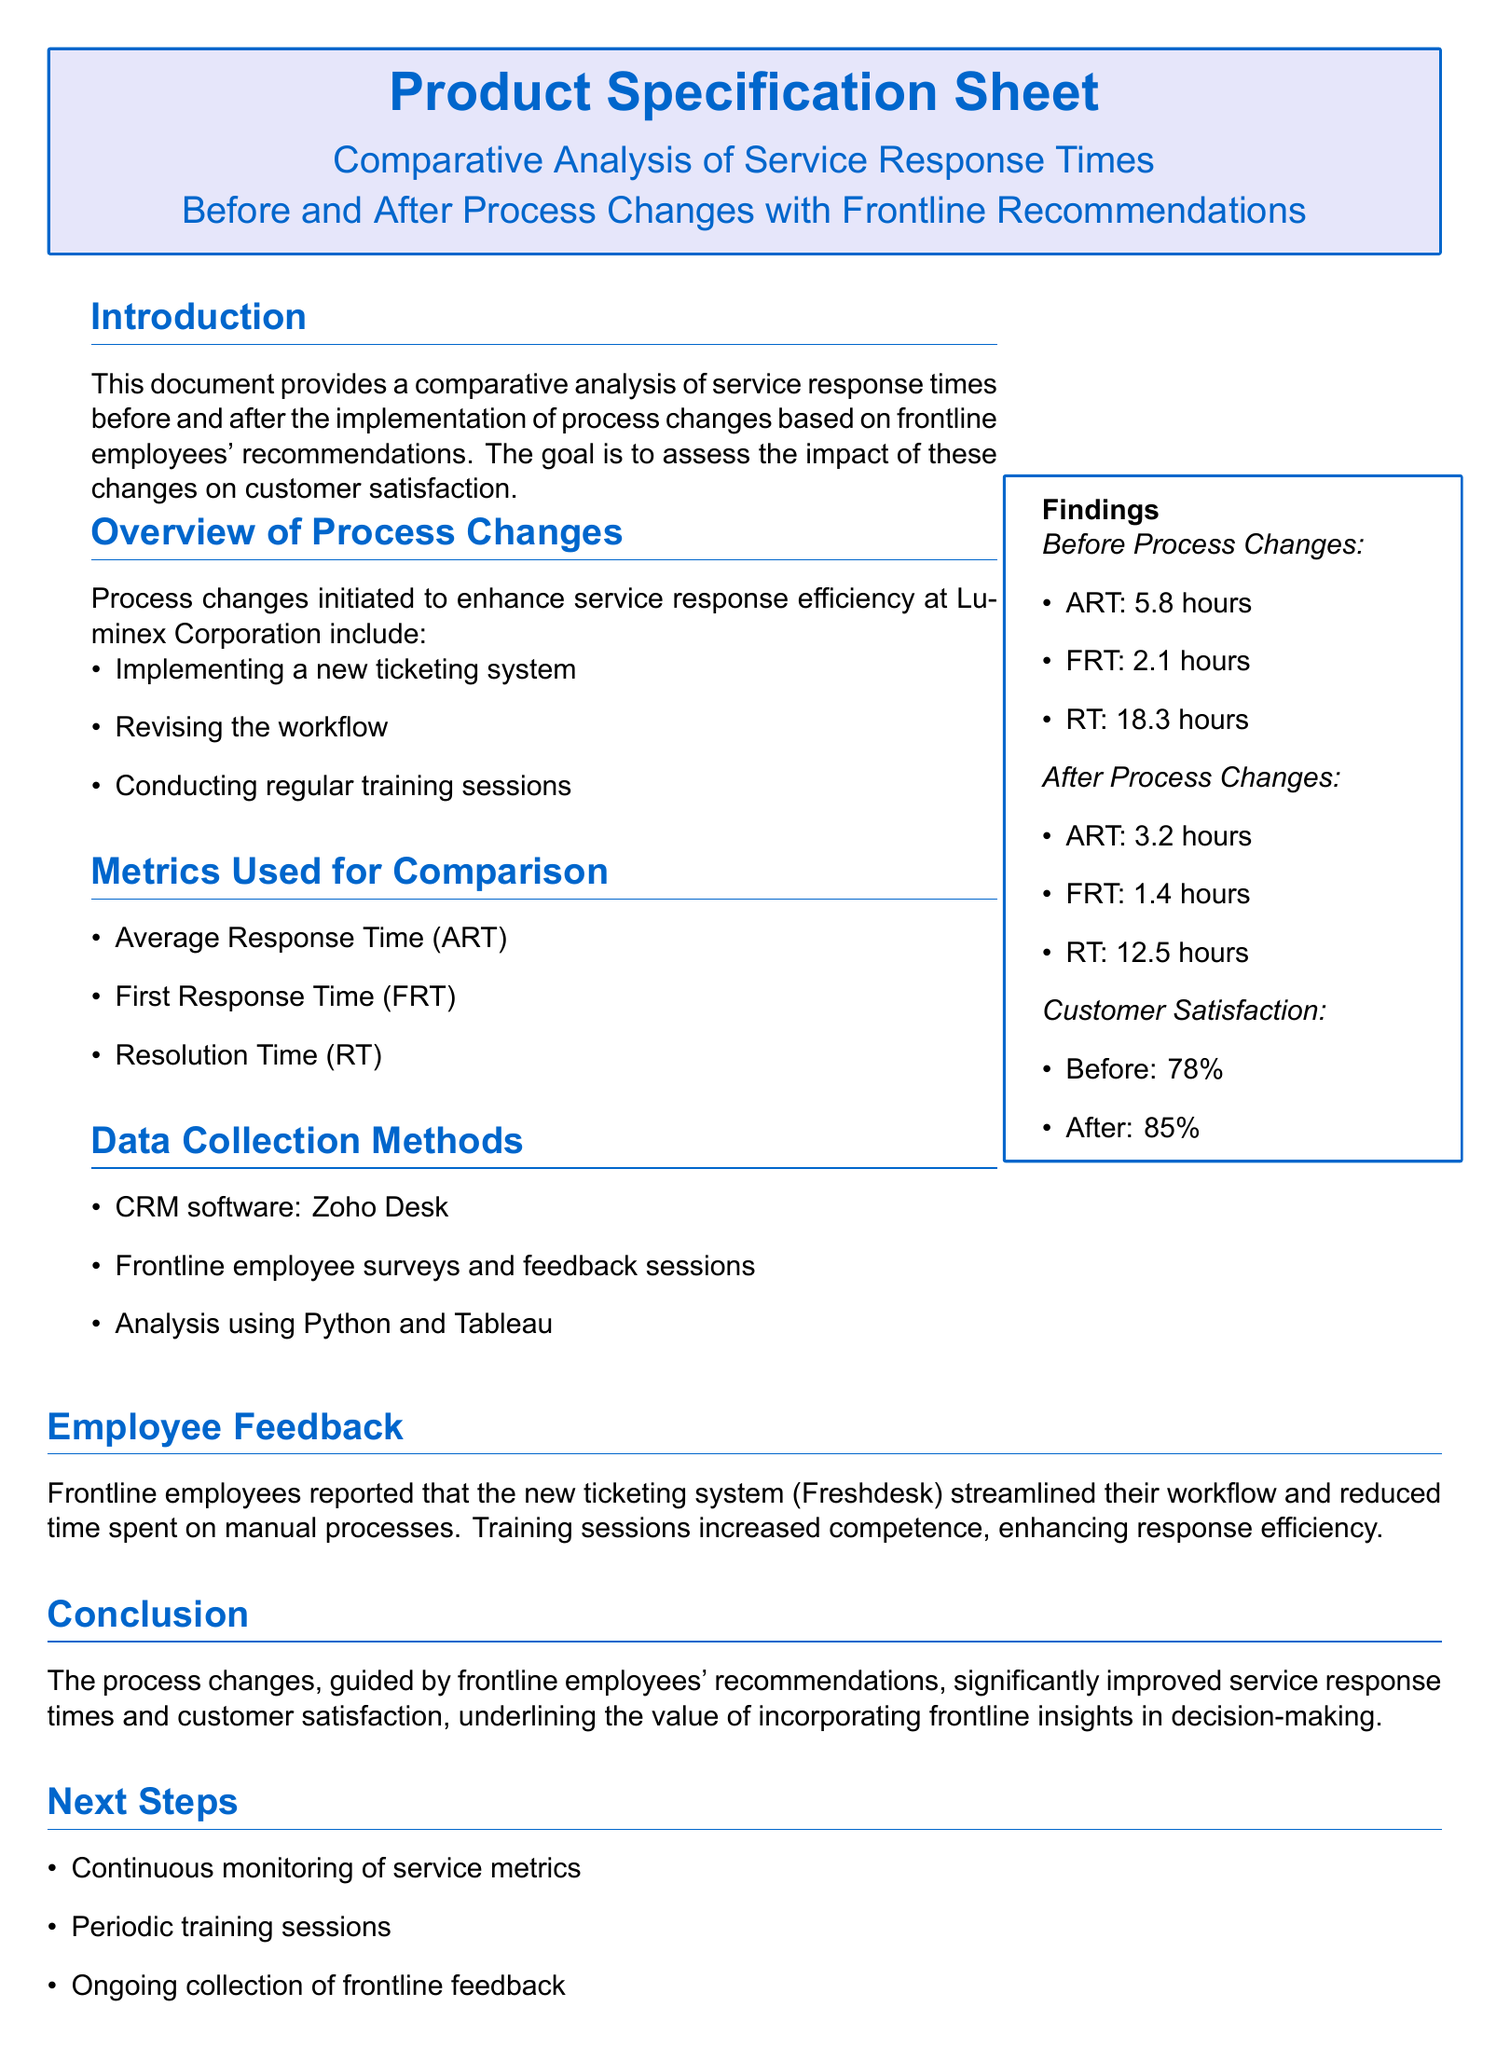What is the average response time before process changes? The average response time before process changes is explicitly stated in the findings section of the document.
Answer: 5.8 hours What percentage of customer satisfaction was reported after the process changes? The customer satisfaction percentage after the process changes is outlined in the findings section.
Answer: 85% What new system was implemented according to the process changes? The new system implemented to enhance service response efficiency is mentioned in the overview of process changes.
Answer: New ticketing system What was the first response time after the changes? The first response time after the process changes is provided in the findings section of the document.
Answer: 1.4 hours What was the resolution time before the process changes? The resolution time before the process changes is detailed in the findings section.
Answer: 18.3 hours How many metrics were used for comparison? The number of metrics used for comparison can be found in the metrics used for comparison section.
Answer: Three What type of employee feedback was reported about the new ticketing system? The feedback regarding the new ticketing system discusses its impact on workflow efficiency and manual processes.
Answer: Streamlined workflow What is the main purpose of this document? The main purpose of the document is summarized in the introduction section.
Answer: Comparative analysis of service response times 